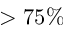Convert formula to latex. <formula><loc_0><loc_0><loc_500><loc_500>> 7 5 \%</formula> 